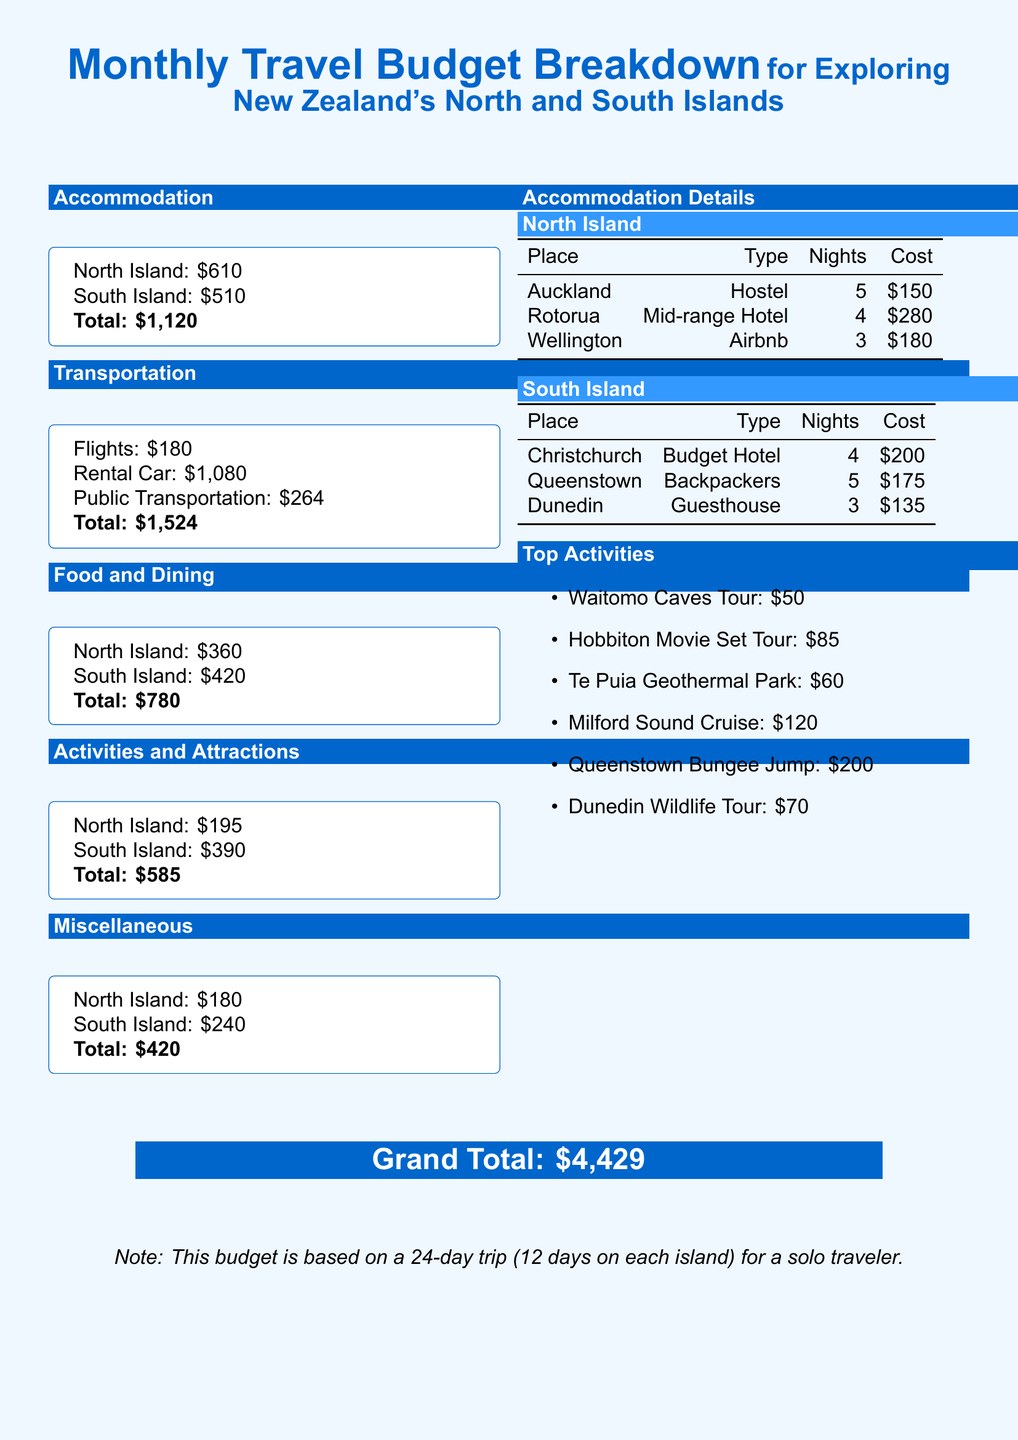What is the total budget for accommodation? The total accommodation cost is provided for both islands, which sums up to $610 + $510 = $1,120.
Answer: $1,120 How much is the rental car expense? The document specifies that the rental car cost is $1,080.
Answer: $1,080 What is the cost of the Milford Sound Cruise? The document lists the Milford Sound Cruise as costing $120.
Answer: $120 How many nights will be spent in Auckland? According to the accommodation details, 5 nights will be spent in Auckland.
Answer: 5 What is the grand total of the travel budget? The grand total is highlighted at the bottom of the document as $4,429.
Answer: $4,429 Which island has the higher food and dining budget? The food and dining budget for the South Island is $420, while the North Island is $360, indicating the South Island has a higher budget.
Answer: South Island What percentage of the total budget is spent on transportation? Transportation cost is $1,524 out of a total budget of $4,429, which is approximately 34.4%.
Answer: Approximately 34.4% How many activities are listed in the top activities section? The document lists six activities under the top activities section.
Answer: 6 What type of accommodation is used in Rotorua? The type of accommodation listed for Rotorua is a mid-range hotel.
Answer: Mid-range Hotel 